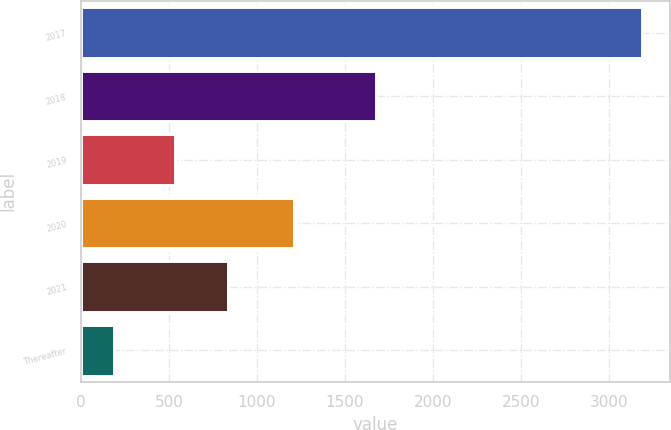Convert chart. <chart><loc_0><loc_0><loc_500><loc_500><bar_chart><fcel>2017<fcel>2018<fcel>2019<fcel>2020<fcel>2021<fcel>Thereafter<nl><fcel>3189<fcel>1674<fcel>533<fcel>1208<fcel>833.2<fcel>187<nl></chart> 